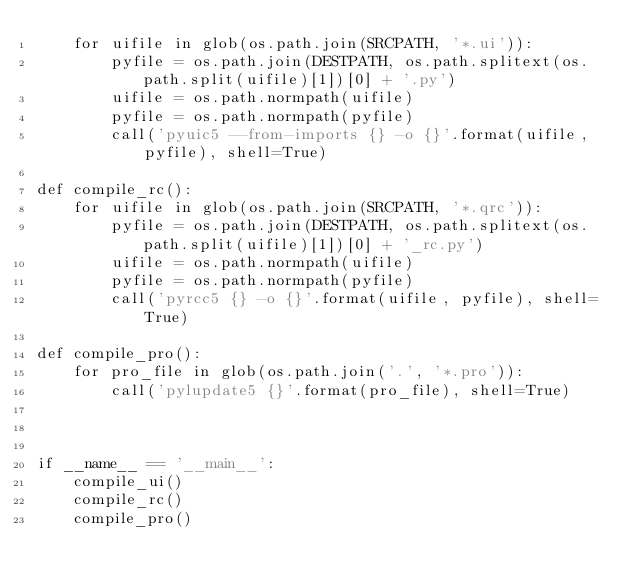<code> <loc_0><loc_0><loc_500><loc_500><_Python_>    for uifile in glob(os.path.join(SRCPATH, '*.ui')):
        pyfile = os.path.join(DESTPATH, os.path.splitext(os.path.split(uifile)[1])[0] + '.py')
        uifile = os.path.normpath(uifile)
        pyfile = os.path.normpath(pyfile)
        call('pyuic5 --from-imports {} -o {}'.format(uifile, pyfile), shell=True)

def compile_rc():
    for uifile in glob(os.path.join(SRCPATH, '*.qrc')):
        pyfile = os.path.join(DESTPATH, os.path.splitext(os.path.split(uifile)[1])[0] + '_rc.py')
        uifile = os.path.normpath(uifile)
        pyfile = os.path.normpath(pyfile)
        call('pyrcc5 {} -o {}'.format(uifile, pyfile), shell=True)

def compile_pro():
    for pro_file in glob(os.path.join('.', '*.pro')):
        call('pylupdate5 {}'.format(pro_file), shell=True)



if __name__ == '__main__':
    compile_ui()
    compile_rc()
    compile_pro()
</code> 